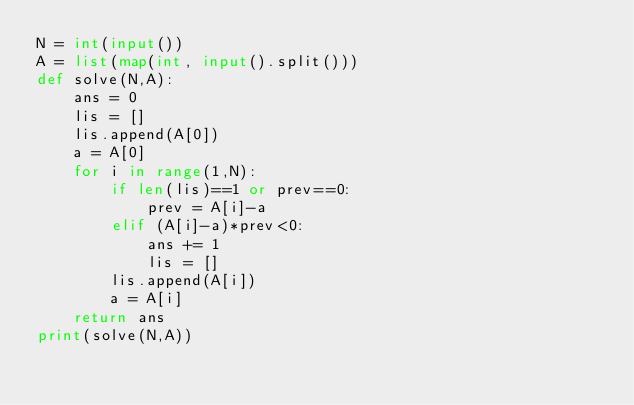<code> <loc_0><loc_0><loc_500><loc_500><_Python_>N = int(input())
A = list(map(int, input().split()))
def solve(N,A):
    ans = 0
    lis = []
    lis.append(A[0])
    a = A[0]
    for i in range(1,N):
        if len(lis)==1 or prev==0:
            prev = A[i]-a
        elif (A[i]-a)*prev<0:
            ans += 1
            lis = []
        lis.append(A[i])
        a = A[i]
    return ans
print(solve(N,A))</code> 